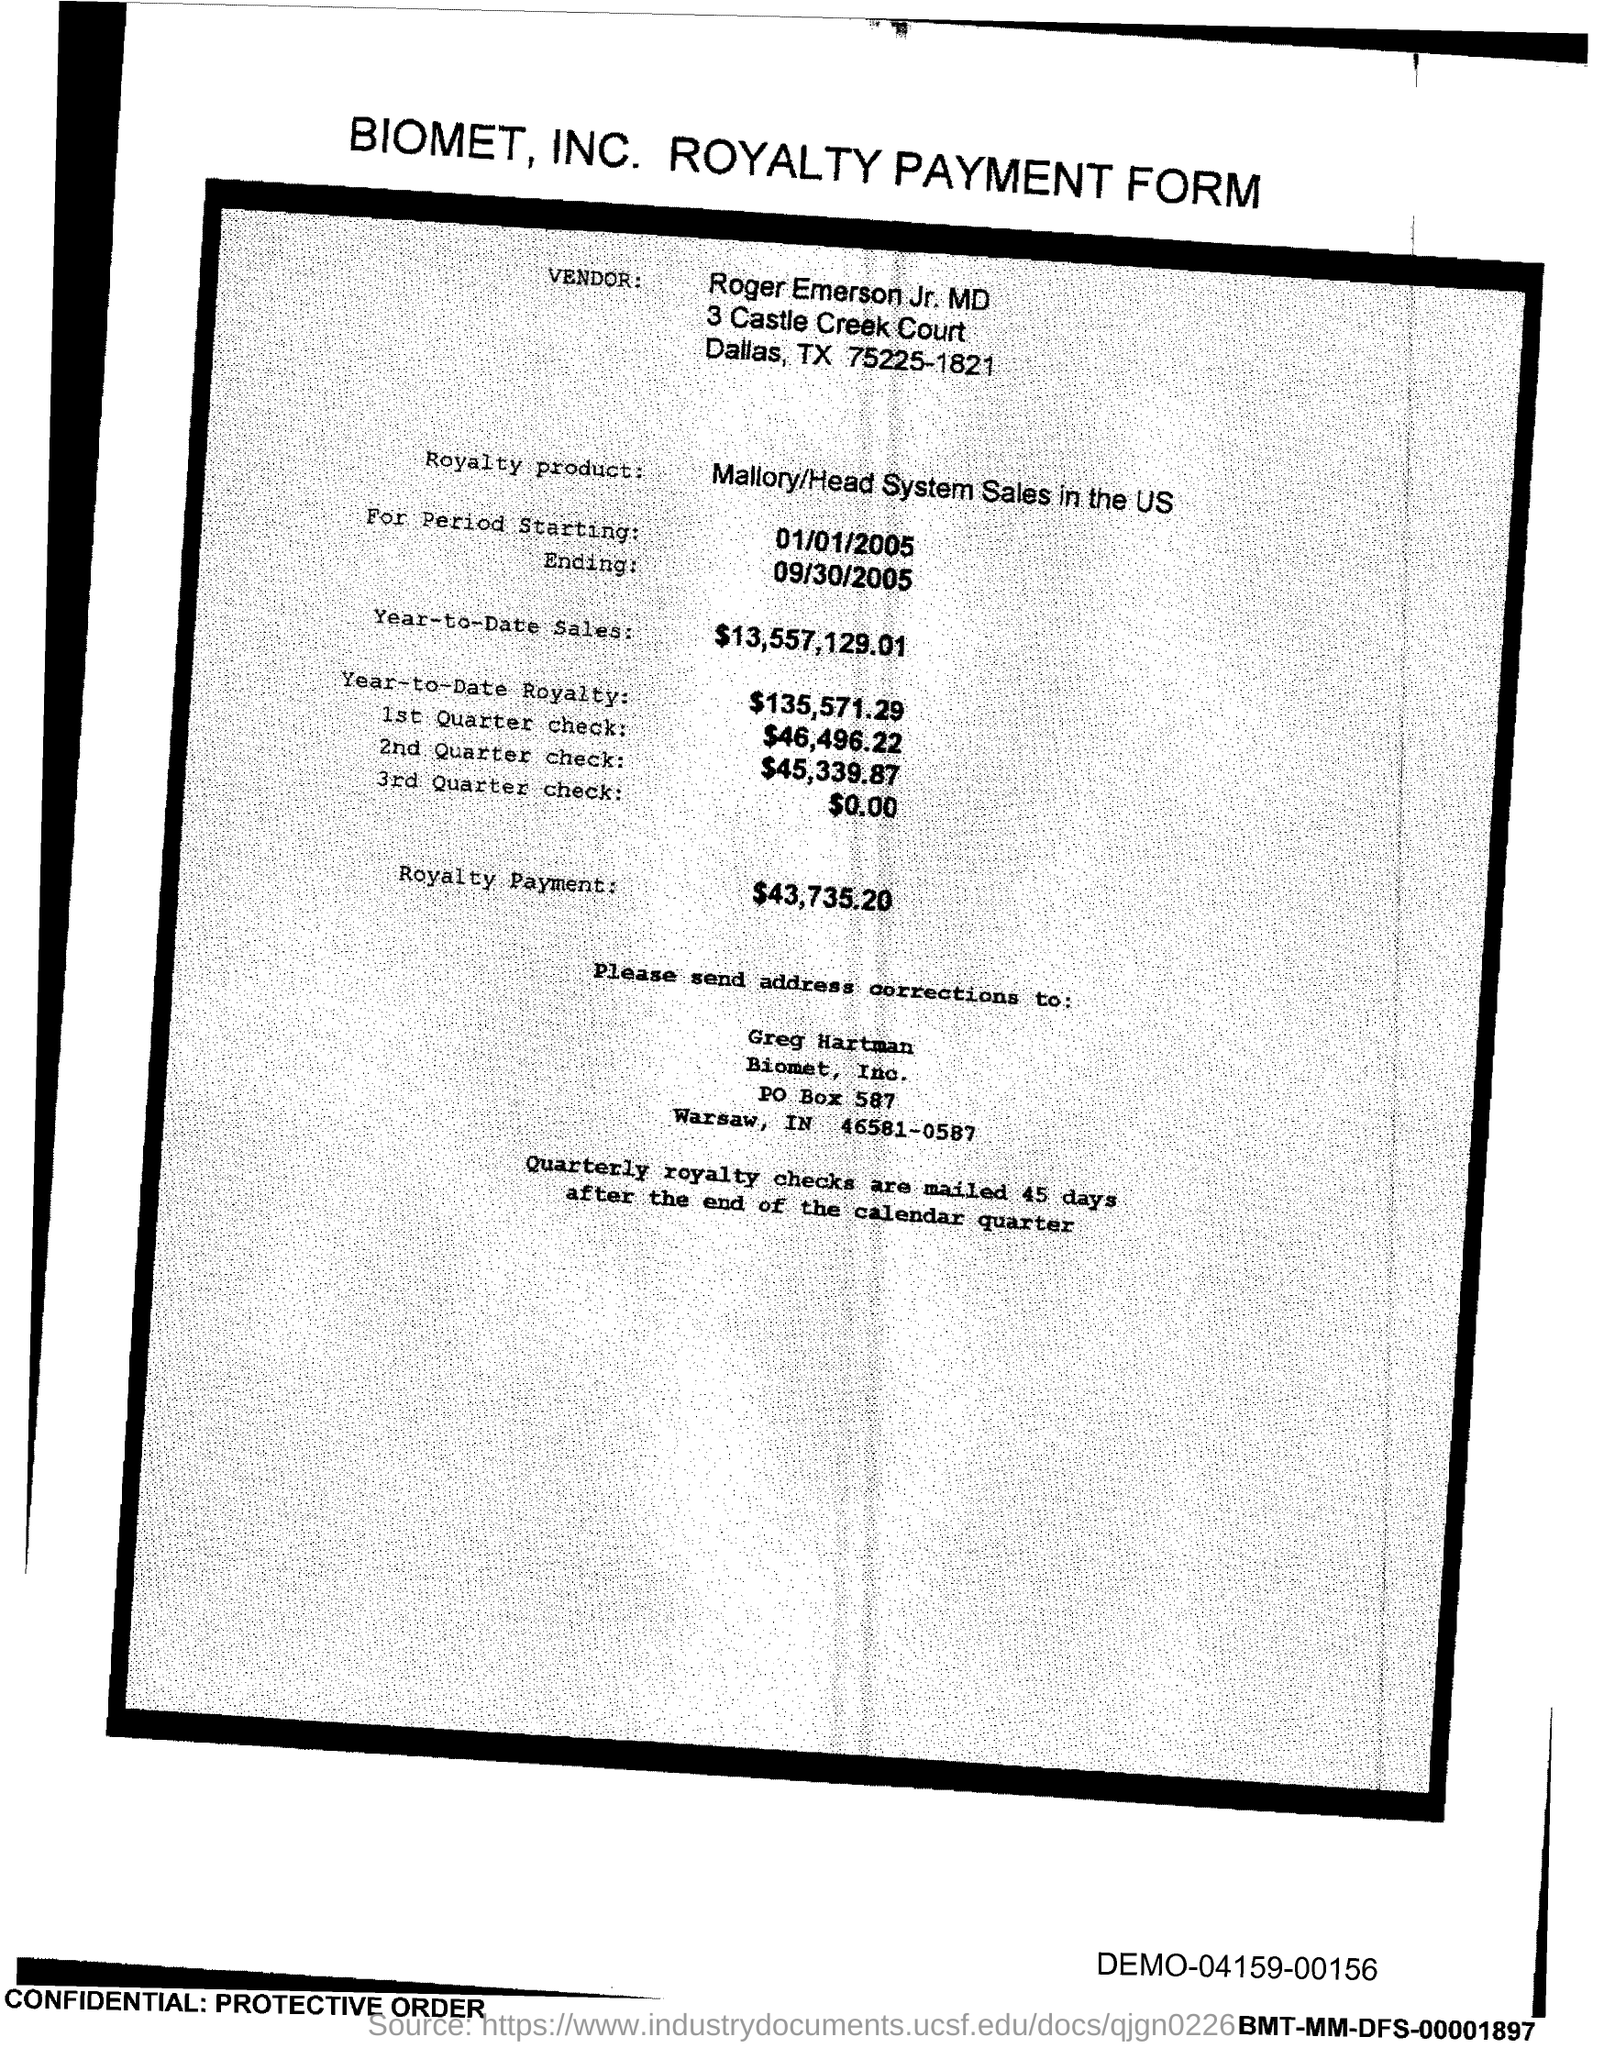Specify some key components in this picture. The PO Box number mentioned in the document is 587. 